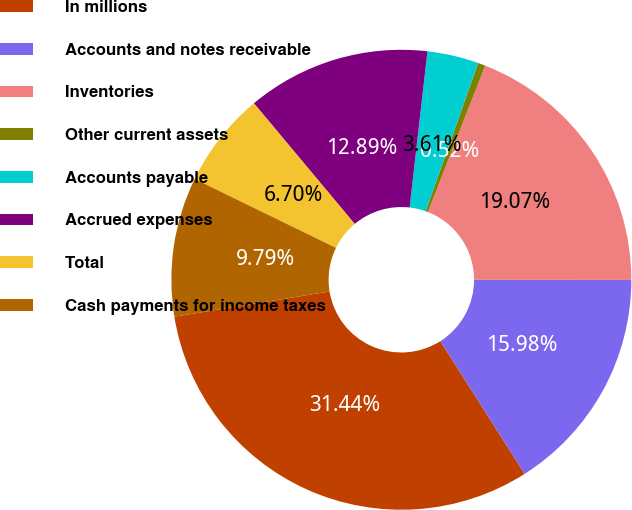Convert chart. <chart><loc_0><loc_0><loc_500><loc_500><pie_chart><fcel>In millions<fcel>Accounts and notes receivable<fcel>Inventories<fcel>Other current assets<fcel>Accounts payable<fcel>Accrued expenses<fcel>Total<fcel>Cash payments for income taxes<nl><fcel>31.44%<fcel>15.98%<fcel>19.07%<fcel>0.52%<fcel>3.61%<fcel>12.89%<fcel>6.7%<fcel>9.79%<nl></chart> 